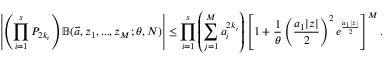<formula> <loc_0><loc_0><loc_500><loc_500>\left | \left ( \prod _ { i = 1 } ^ { s } P _ { 2 k _ { i } } \right ) \mathbb { B } ( \ V e c { a } , z _ { 1 } , \dots , z _ { M } ; \theta , N ) \right | \leq \prod _ { i = 1 } ^ { s } \left ( \sum _ { j = 1 } ^ { M } a _ { i } ^ { 2 k _ { i } } \right ) \left [ 1 + \frac { 1 } { \theta } \left ( \frac { a _ { 1 } | z | } { 2 } \right ) ^ { 2 } e ^ { \frac { a _ { 1 } | z | } { 2 } } \right ] ^ { M } .</formula> 